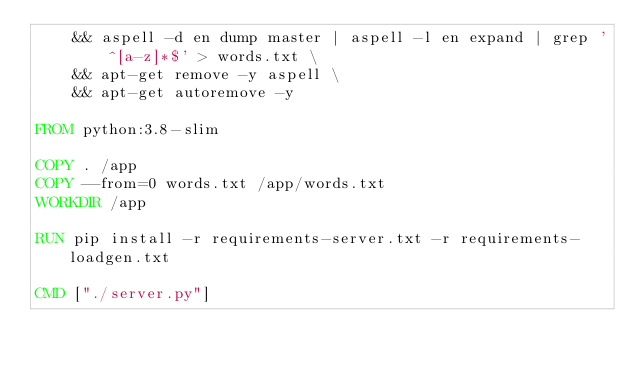Convert code to text. <code><loc_0><loc_0><loc_500><loc_500><_Dockerfile_>    && aspell -d en dump master | aspell -l en expand | grep '^[a-z]*$' > words.txt \
    && apt-get remove -y aspell \
    && apt-get autoremove -y

FROM python:3.8-slim

COPY . /app
COPY --from=0 words.txt /app/words.txt
WORKDIR /app

RUN pip install -r requirements-server.txt -r requirements-loadgen.txt

CMD ["./server.py"]
</code> 